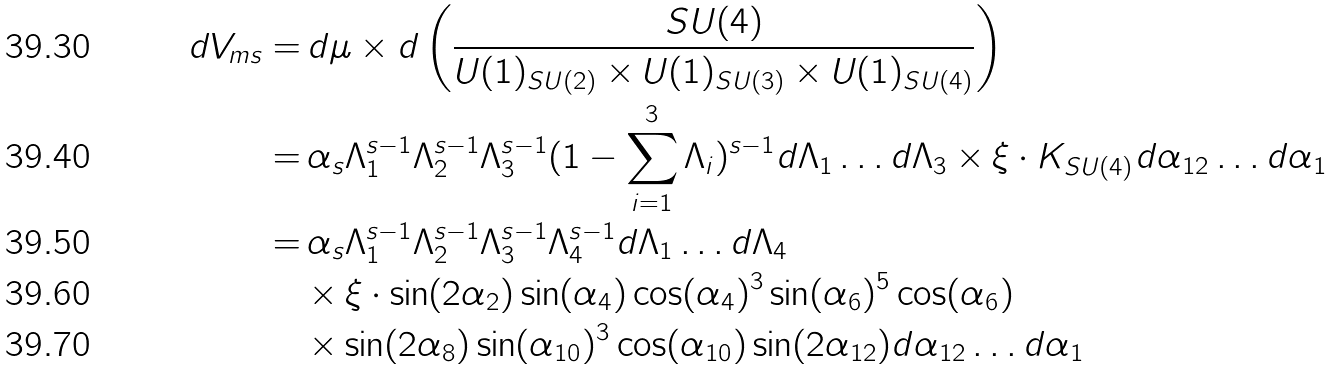Convert formula to latex. <formula><loc_0><loc_0><loc_500><loc_500>d V _ { m s } = & \, d \mu \times d \left ( \frac { S U ( 4 ) } { U ( 1 ) _ { S U ( 2 ) } \times U ( 1 ) _ { S U ( 3 ) } \times U ( 1 ) _ { S U ( 4 ) } } \right ) \\ = & \, \alpha _ { s } \Lambda _ { 1 } ^ { s - 1 } \Lambda _ { 2 } ^ { s - 1 } \Lambda _ { 3 } ^ { s - 1 } ( 1 - \sum _ { i = 1 } ^ { 3 } \Lambda _ { i } ) ^ { s - 1 } d \Lambda _ { 1 } \dots d \Lambda _ { 3 } \times \xi \cdot K _ { S U ( 4 ) } d \alpha _ { 1 2 } \dots d \alpha _ { 1 } \\ = & \, \alpha _ { s } \Lambda _ { 1 } ^ { s - 1 } \Lambda _ { 2 } ^ { s - 1 } \Lambda _ { 3 } ^ { s - 1 } \Lambda _ { 4 } ^ { s - 1 } d \Lambda _ { 1 } \dots d \Lambda _ { 4 } \\ & \times \xi \cdot \sin ( 2 \alpha _ { 2 } ) \sin ( \alpha _ { 4 } ) \cos ( \alpha _ { 4 } ) ^ { 3 } \sin ( \alpha _ { 6 } ) ^ { 5 } \cos ( \alpha _ { 6 } ) \\ & \times \sin ( 2 \alpha _ { 8 } ) \sin ( \alpha _ { 1 0 } ) ^ { 3 } \cos ( \alpha _ { 1 0 } ) \sin ( 2 \alpha _ { 1 2 } ) d \alpha _ { 1 2 } \dots d \alpha _ { 1 }</formula> 